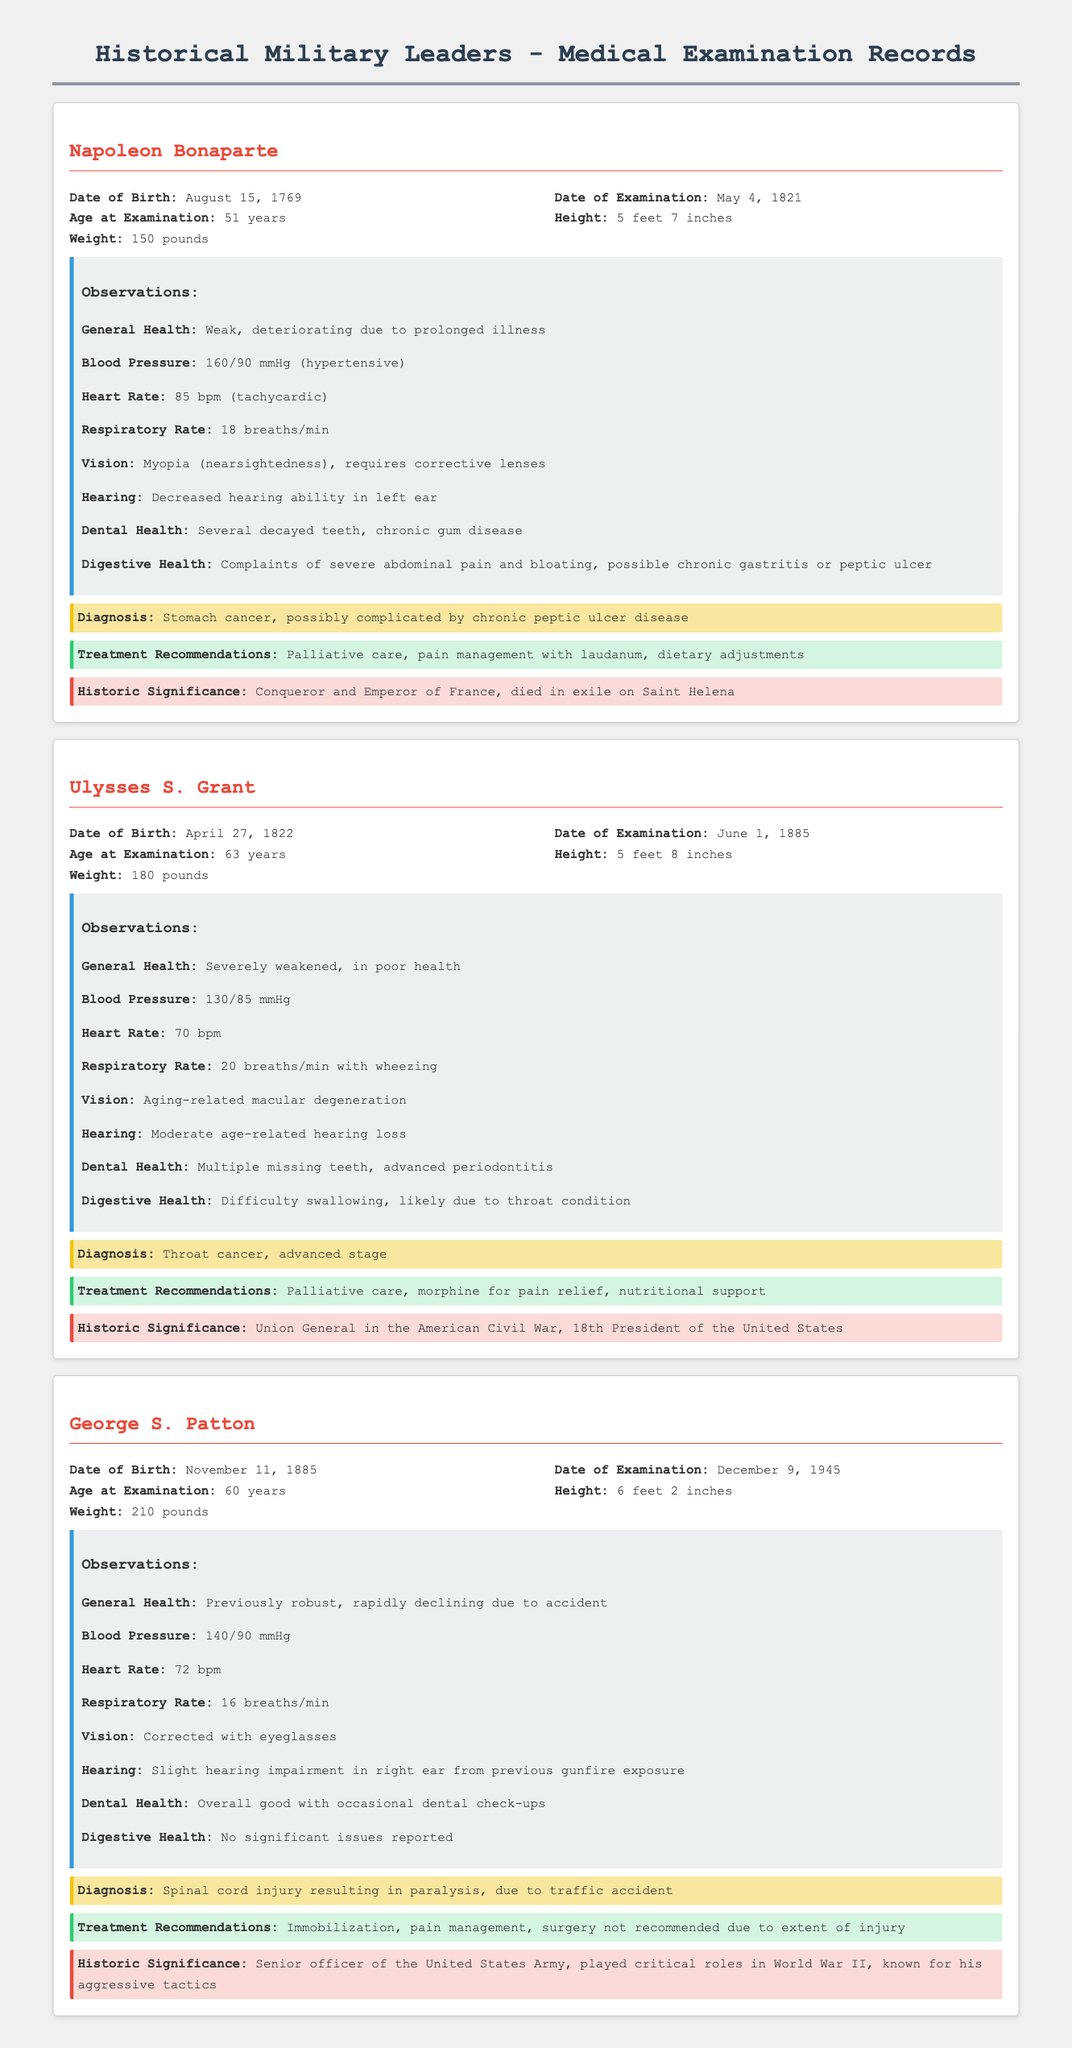What is the date of examination for Napoleon Bonaparte? The date of examination for Napoleon Bonaparte is provided in the record under "Date of Examination."
Answer: May 4, 1821 What was Ulysses S. Grant's diagnosis? The diagnosis for Ulysses S. Grant is stated in the record under "Diagnosis."
Answer: Throat cancer, advanced stage How tall was George S. Patton? The height of George S. Patton is mentioned in the record under "Height."
Answer: 6 feet 2 inches What was Napoleon Bonaparte's blood pressure reading? The blood pressure reading for Napoleon Bonaparte is recorded under "Blood Pressure."
Answer: 160/90 mmHg What treatment was recommended for George S. Patton? The treatment recommendations for George S. Patton can be found under "Treatment Recommendations."
Answer: Immobilization, pain management, surgery not recommended due to extent of injury Which military leader had complaints of severe abdominal pain? The document states this issue under "Digestive Health" for Napoleon Bonaparte.
Answer: Napoleon Bonaparte What health issue is associated with Ulysses S. Grant's eyesight? The observations on vision for Ulysses S. Grant describe a specific condition noted in the record.
Answer: Aging-related macular degeneration What is the historic significance of George S. Patton? The historic significance is detailed in the record under "Historic Significance," summarizing his contributions.
Answer: Senior officer of the United States Army, played critical roles in World War II, known for his aggressive tactics 